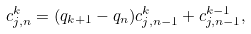Convert formula to latex. <formula><loc_0><loc_0><loc_500><loc_500>c _ { j , n } ^ { k } = ( q _ { k + 1 } - q _ { n } ) c _ { j , n - 1 } ^ { k } + c _ { j , n - 1 } ^ { k - 1 } ,</formula> 